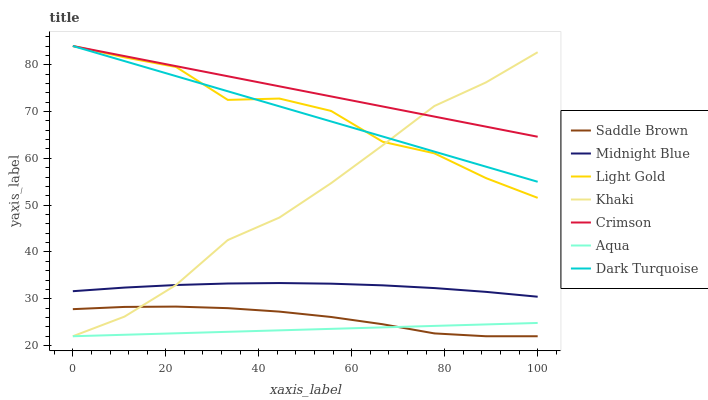Does Aqua have the minimum area under the curve?
Answer yes or no. Yes. Does Crimson have the maximum area under the curve?
Answer yes or no. Yes. Does Midnight Blue have the minimum area under the curve?
Answer yes or no. No. Does Midnight Blue have the maximum area under the curve?
Answer yes or no. No. Is Aqua the smoothest?
Answer yes or no. Yes. Is Light Gold the roughest?
Answer yes or no. Yes. Is Midnight Blue the smoothest?
Answer yes or no. No. Is Midnight Blue the roughest?
Answer yes or no. No. Does Midnight Blue have the lowest value?
Answer yes or no. No. Does Light Gold have the highest value?
Answer yes or no. Yes. Does Midnight Blue have the highest value?
Answer yes or no. No. Is Aqua less than Dark Turquoise?
Answer yes or no. Yes. Is Light Gold greater than Saddle Brown?
Answer yes or no. Yes. Does Light Gold intersect Khaki?
Answer yes or no. Yes. Is Light Gold less than Khaki?
Answer yes or no. No. Is Light Gold greater than Khaki?
Answer yes or no. No. Does Aqua intersect Dark Turquoise?
Answer yes or no. No. 